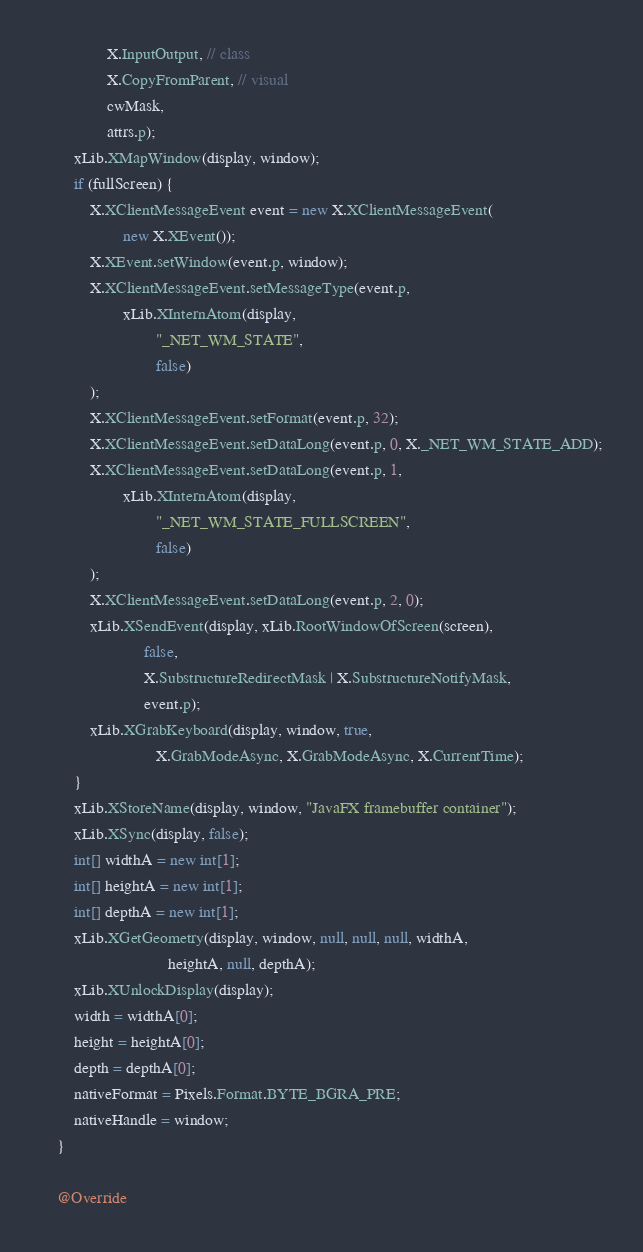<code> <loc_0><loc_0><loc_500><loc_500><_Java_>                X.InputOutput, // class
                X.CopyFromParent, // visual
                cwMask,
                attrs.p);
        xLib.XMapWindow(display, window);
        if (fullScreen) {
            X.XClientMessageEvent event = new X.XClientMessageEvent(
                    new X.XEvent());
            X.XEvent.setWindow(event.p, window);
            X.XClientMessageEvent.setMessageType(event.p,
                    xLib.XInternAtom(display,
                            "_NET_WM_STATE",
                            false)
            );
            X.XClientMessageEvent.setFormat(event.p, 32);
            X.XClientMessageEvent.setDataLong(event.p, 0, X._NET_WM_STATE_ADD);
            X.XClientMessageEvent.setDataLong(event.p, 1,
                    xLib.XInternAtom(display,
                            "_NET_WM_STATE_FULLSCREEN",
                            false)
            );
            X.XClientMessageEvent.setDataLong(event.p, 2, 0);
            xLib.XSendEvent(display, xLib.RootWindowOfScreen(screen),
                         false,
                         X.SubstructureRedirectMask | X.SubstructureNotifyMask,
                         event.p);
            xLib.XGrabKeyboard(display, window, true,
                            X.GrabModeAsync, X.GrabModeAsync, X.CurrentTime);
        }
        xLib.XStoreName(display, window, "JavaFX framebuffer container");
        xLib.XSync(display, false);
        int[] widthA = new int[1];
        int[] heightA = new int[1];
        int[] depthA = new int[1];
        xLib.XGetGeometry(display, window, null, null, null, widthA,
                               heightA, null, depthA);
        xLib.XUnlockDisplay(display);
        width = widthA[0];
        height = heightA[0];
        depth = depthA[0];
        nativeFormat = Pixels.Format.BYTE_BGRA_PRE;
        nativeHandle = window;
    }

    @Override</code> 